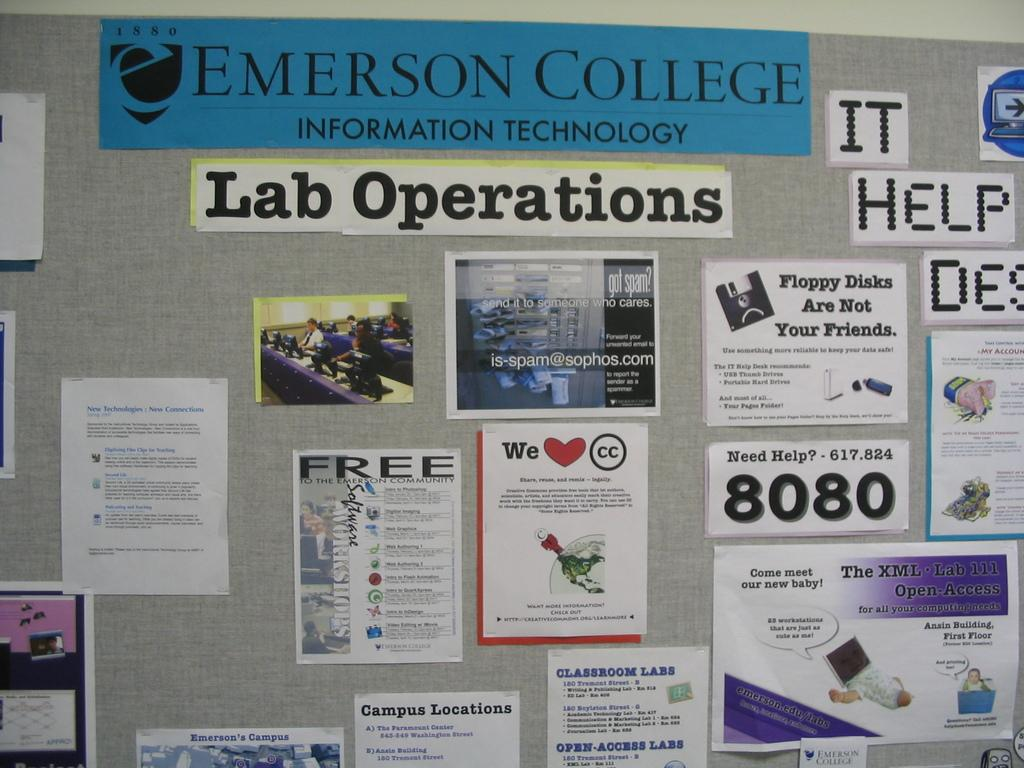<image>
Render a clear and concise summary of the photo. A wall in a building at Emerson College displays a number of posters and messages. 